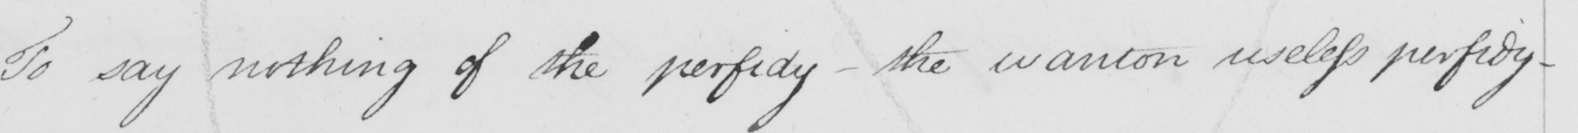Please transcribe the handwritten text in this image. To say nothing of the perfidy  _  the wanton useless perfidy  _ 